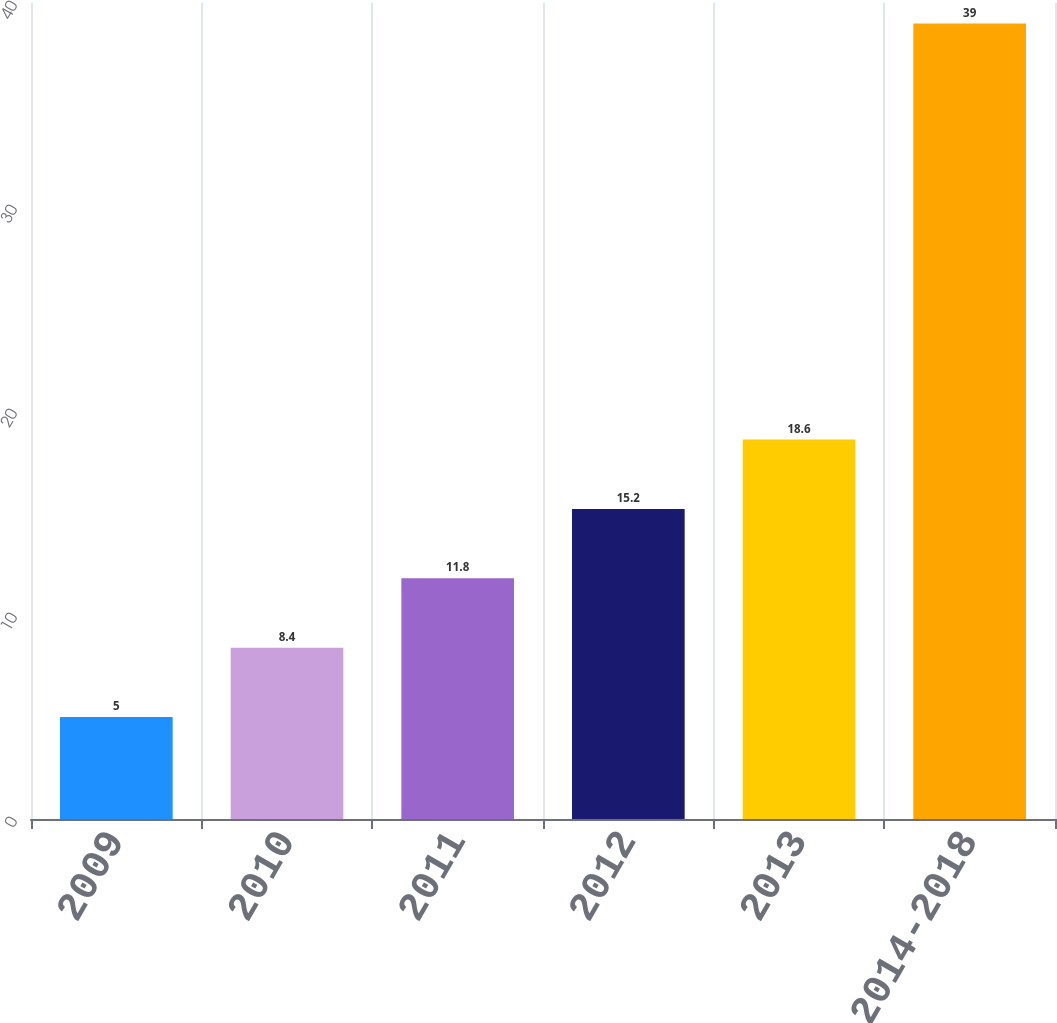Convert chart. <chart><loc_0><loc_0><loc_500><loc_500><bar_chart><fcel>2009<fcel>2010<fcel>2011<fcel>2012<fcel>2013<fcel>2014-2018<nl><fcel>5<fcel>8.4<fcel>11.8<fcel>15.2<fcel>18.6<fcel>39<nl></chart> 